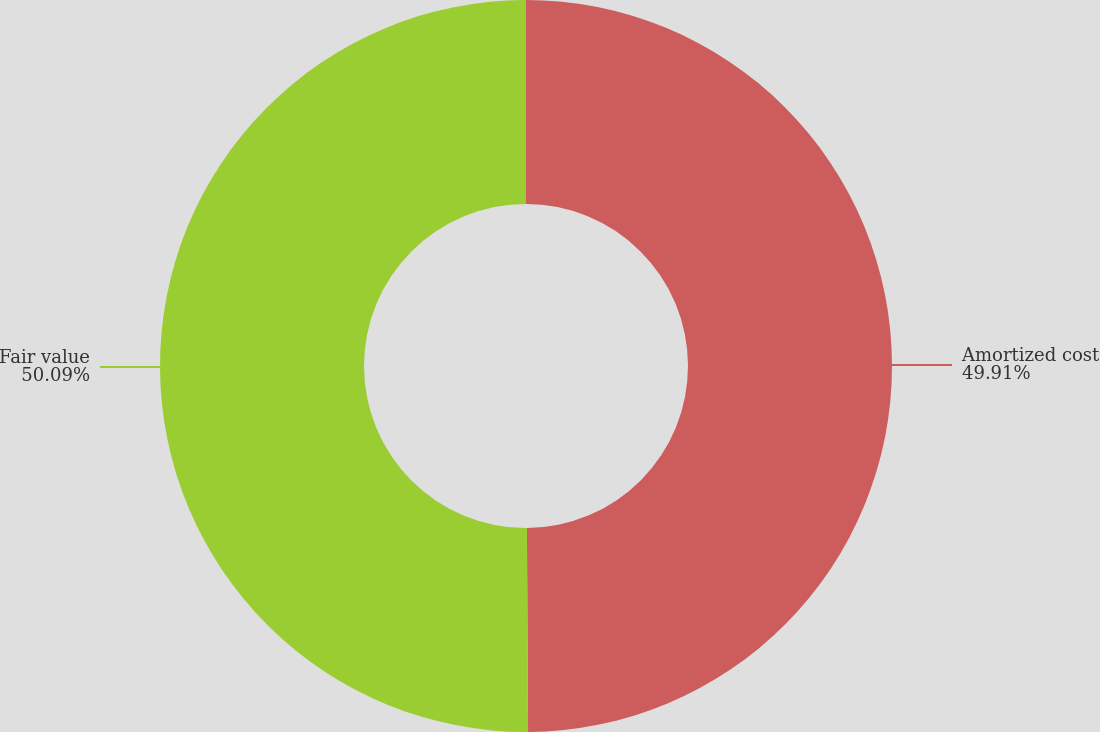<chart> <loc_0><loc_0><loc_500><loc_500><pie_chart><fcel>Amortized cost<fcel>Fair value<nl><fcel>49.91%<fcel>50.09%<nl></chart> 